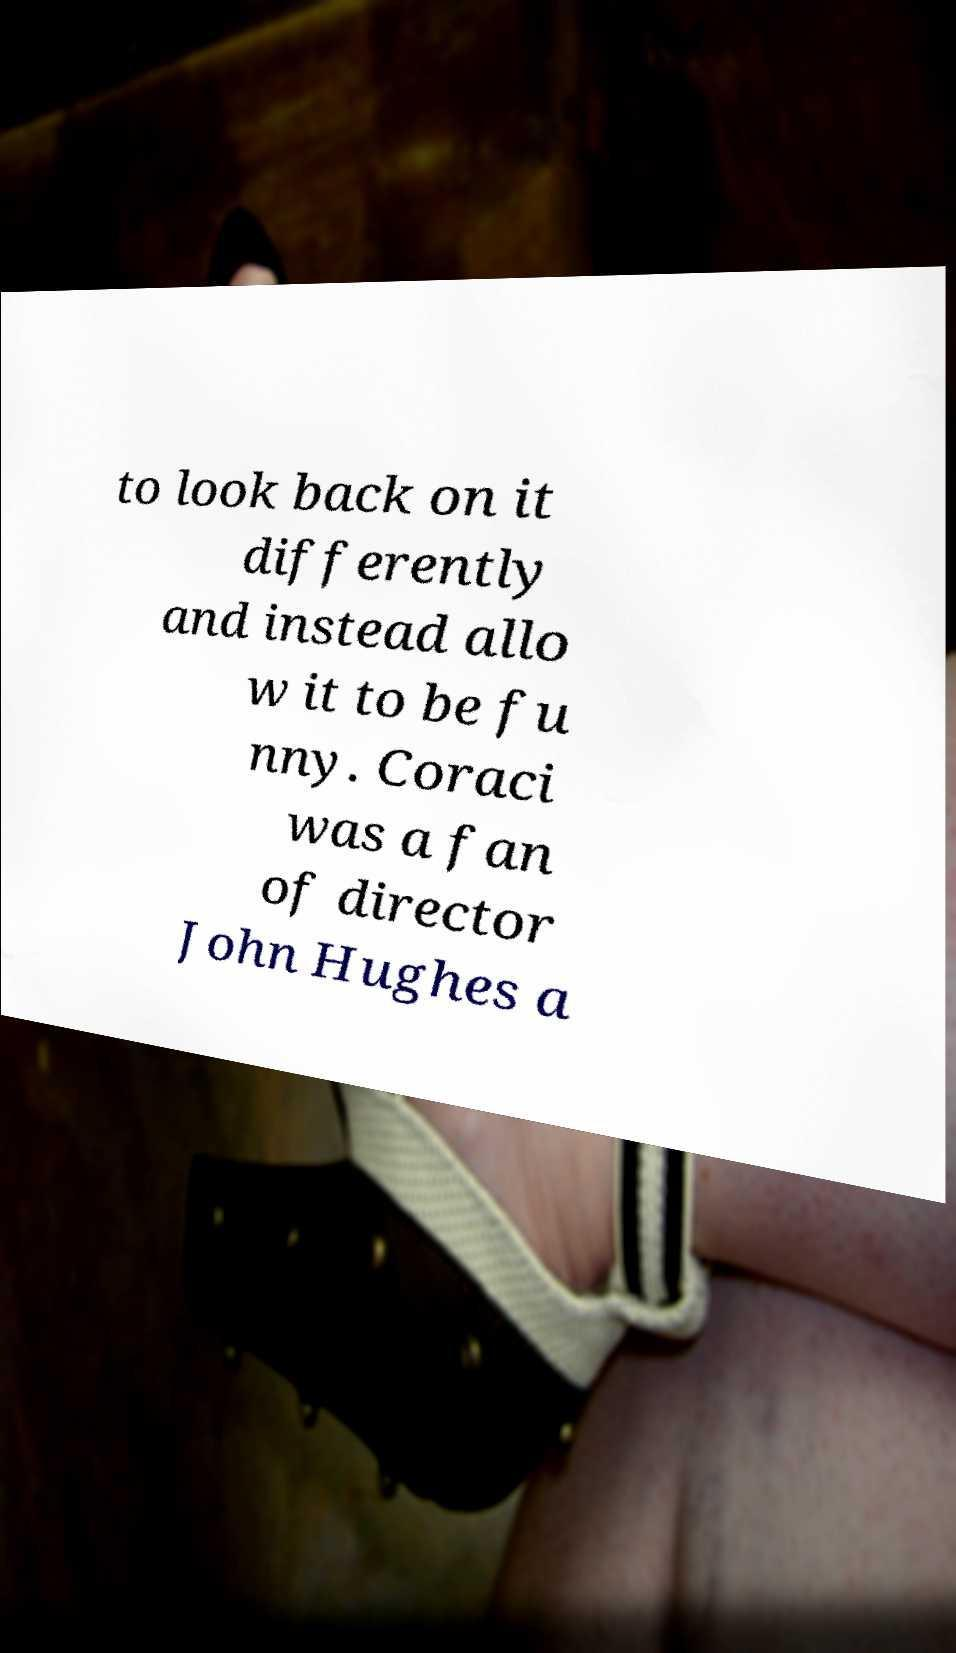There's text embedded in this image that I need extracted. Can you transcribe it verbatim? to look back on it differently and instead allo w it to be fu nny. Coraci was a fan of director John Hughes a 